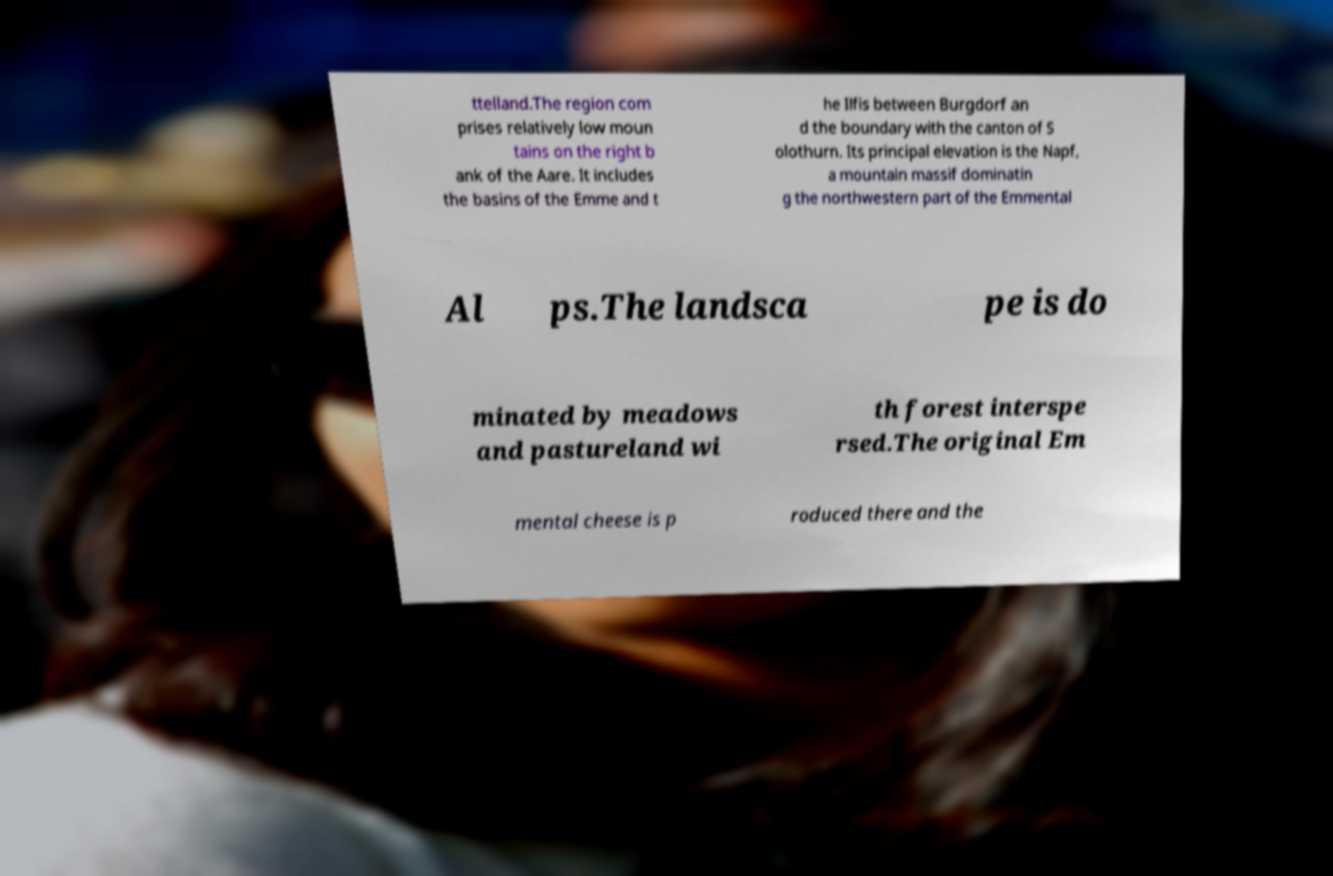There's text embedded in this image that I need extracted. Can you transcribe it verbatim? ttelland.The region com prises relatively low moun tains on the right b ank of the Aare. It includes the basins of the Emme and t he Ilfis between Burgdorf an d the boundary with the canton of S olothurn. Its principal elevation is the Napf, a mountain massif dominatin g the northwestern part of the Emmental Al ps.The landsca pe is do minated by meadows and pastureland wi th forest interspe rsed.The original Em mental cheese is p roduced there and the 